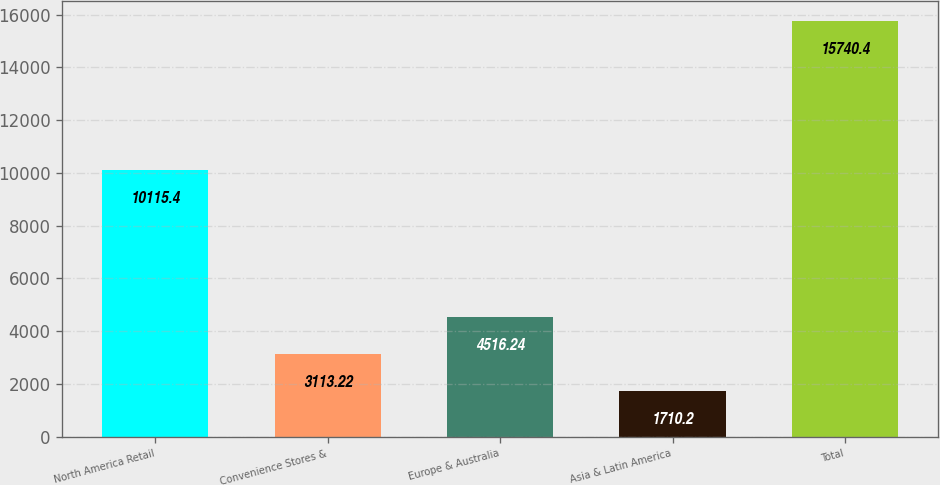Convert chart to OTSL. <chart><loc_0><loc_0><loc_500><loc_500><bar_chart><fcel>North America Retail<fcel>Convenience Stores &<fcel>Europe & Australia<fcel>Asia & Latin America<fcel>Total<nl><fcel>10115.4<fcel>3113.22<fcel>4516.24<fcel>1710.2<fcel>15740.4<nl></chart> 